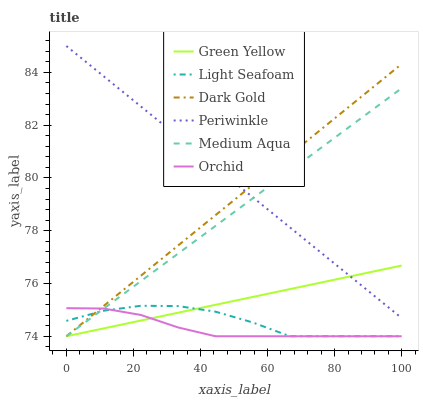Does Orchid have the minimum area under the curve?
Answer yes or no. Yes. Does Periwinkle have the maximum area under the curve?
Answer yes or no. Yes. Does Dark Gold have the minimum area under the curve?
Answer yes or no. No. Does Dark Gold have the maximum area under the curve?
Answer yes or no. No. Is Periwinkle the smoothest?
Answer yes or no. Yes. Is Light Seafoam the roughest?
Answer yes or no. Yes. Is Dark Gold the smoothest?
Answer yes or no. No. Is Dark Gold the roughest?
Answer yes or no. No. Does Light Seafoam have the lowest value?
Answer yes or no. Yes. Does Periwinkle have the lowest value?
Answer yes or no. No. Does Periwinkle have the highest value?
Answer yes or no. Yes. Does Dark Gold have the highest value?
Answer yes or no. No. Is Orchid less than Periwinkle?
Answer yes or no. Yes. Is Periwinkle greater than Light Seafoam?
Answer yes or no. Yes. Does Medium Aqua intersect Orchid?
Answer yes or no. Yes. Is Medium Aqua less than Orchid?
Answer yes or no. No. Is Medium Aqua greater than Orchid?
Answer yes or no. No. Does Orchid intersect Periwinkle?
Answer yes or no. No. 